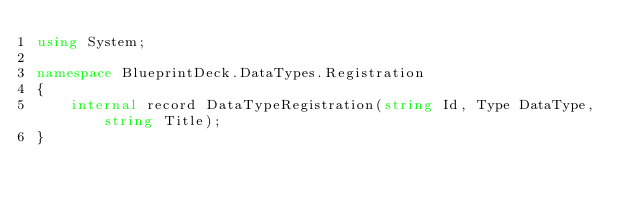Convert code to text. <code><loc_0><loc_0><loc_500><loc_500><_C#_>using System;

namespace BlueprintDeck.DataTypes.Registration
{
    internal record DataTypeRegistration(string Id, Type DataType, string Title);
}</code> 